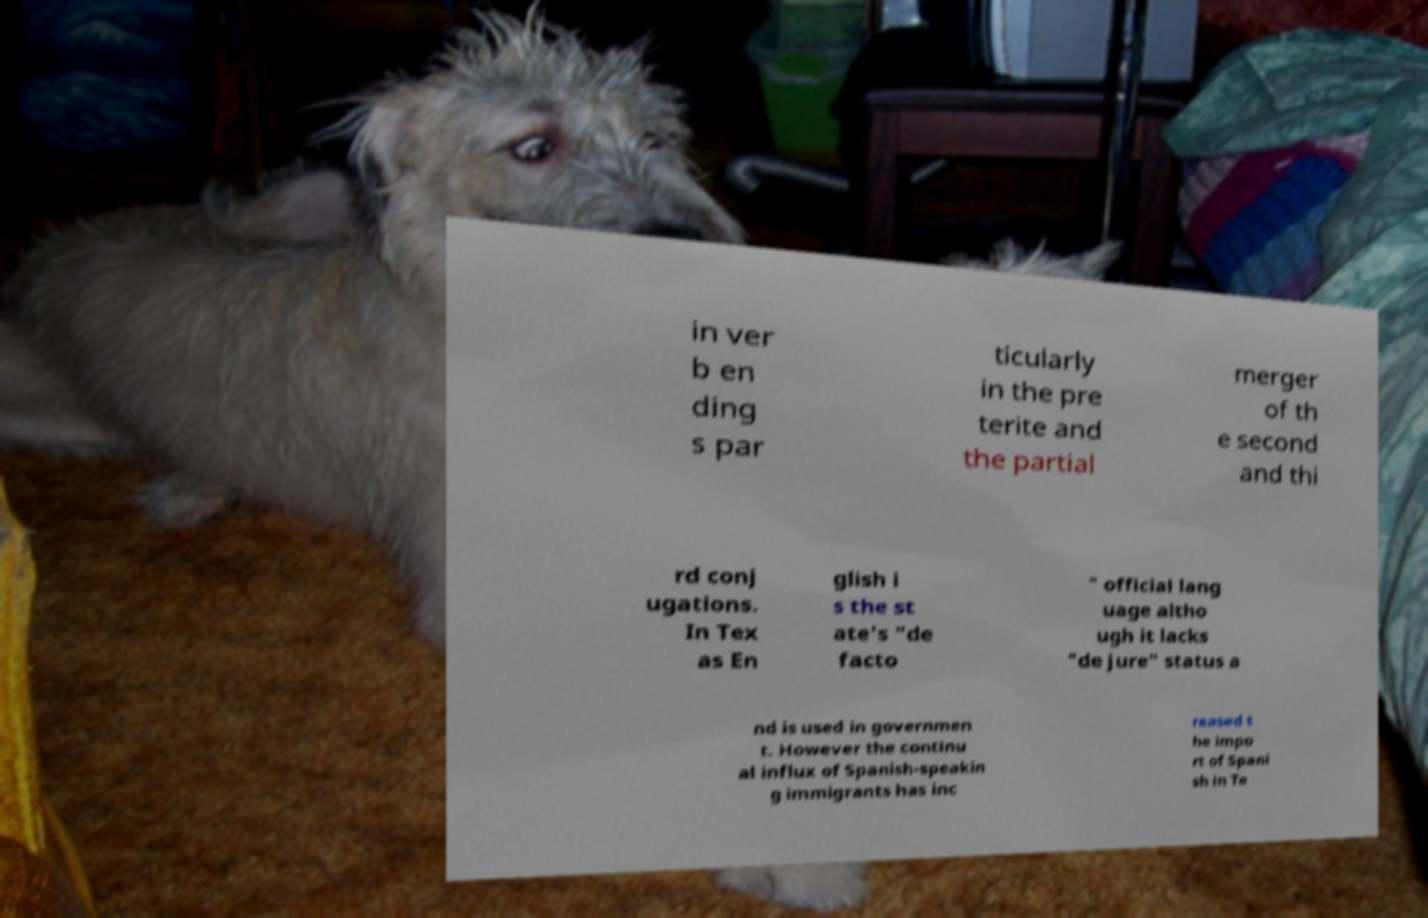There's text embedded in this image that I need extracted. Can you transcribe it verbatim? in ver b en ding s par ticularly in the pre terite and the partial merger of th e second and thi rd conj ugations. In Tex as En glish i s the st ate's "de facto " official lang uage altho ugh it lacks "de jure" status a nd is used in governmen t. However the continu al influx of Spanish-speakin g immigrants has inc reased t he impo rt of Spani sh in Te 